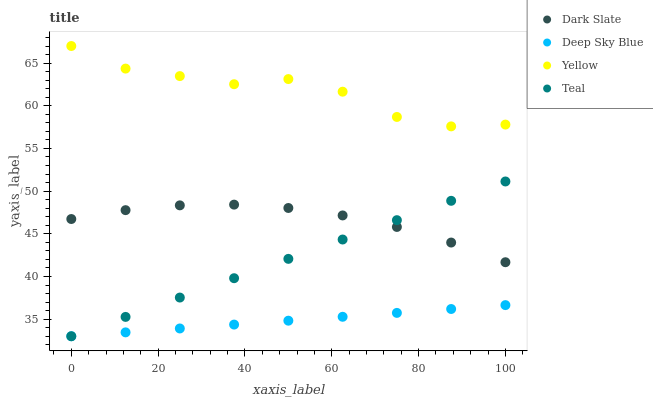Does Deep Sky Blue have the minimum area under the curve?
Answer yes or no. Yes. Does Yellow have the maximum area under the curve?
Answer yes or no. Yes. Does Dark Slate have the minimum area under the curve?
Answer yes or no. No. Does Dark Slate have the maximum area under the curve?
Answer yes or no. No. Is Teal the smoothest?
Answer yes or no. Yes. Is Yellow the roughest?
Answer yes or no. Yes. Is Dark Slate the smoothest?
Answer yes or no. No. Is Dark Slate the roughest?
Answer yes or no. No. Does Teal have the lowest value?
Answer yes or no. Yes. Does Dark Slate have the lowest value?
Answer yes or no. No. Does Yellow have the highest value?
Answer yes or no. Yes. Does Dark Slate have the highest value?
Answer yes or no. No. Is Deep Sky Blue less than Dark Slate?
Answer yes or no. Yes. Is Yellow greater than Dark Slate?
Answer yes or no. Yes. Does Dark Slate intersect Teal?
Answer yes or no. Yes. Is Dark Slate less than Teal?
Answer yes or no. No. Is Dark Slate greater than Teal?
Answer yes or no. No. Does Deep Sky Blue intersect Dark Slate?
Answer yes or no. No. 